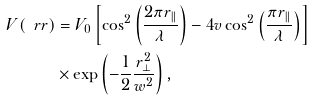<formula> <loc_0><loc_0><loc_500><loc_500>V ( \ r r ) & = V _ { 0 } \left [ \cos ^ { 2 } \left ( \frac { 2 \pi r _ { \| } } { \lambda } \right ) - 4 v \cos ^ { 2 } \left ( \frac { \pi r _ { \| } } { \lambda } \right ) \right ] \\ & \times \exp \left ( - \frac { 1 } { 2 } \frac { r _ { \perp } ^ { 2 } } { w ^ { 2 } } \right ) ,</formula> 